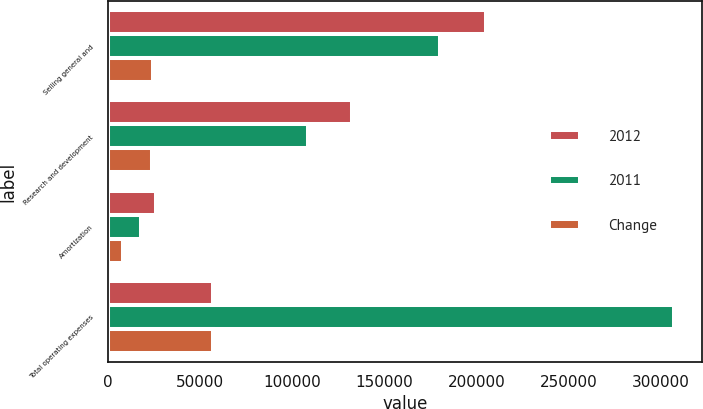Convert chart. <chart><loc_0><loc_0><loc_500><loc_500><stacked_bar_chart><ecel><fcel>Selling general and<fcel>Research and development<fcel>Amortization<fcel>Total operating expenses<nl><fcel>2012<fcel>205178<fcel>132628<fcel>26443<fcel>57373<nl><fcel>2011<fcel>180357<fcel>108530<fcel>17989<fcel>306876<nl><fcel>Change<fcel>24821<fcel>24098<fcel>8454<fcel>57373<nl></chart> 